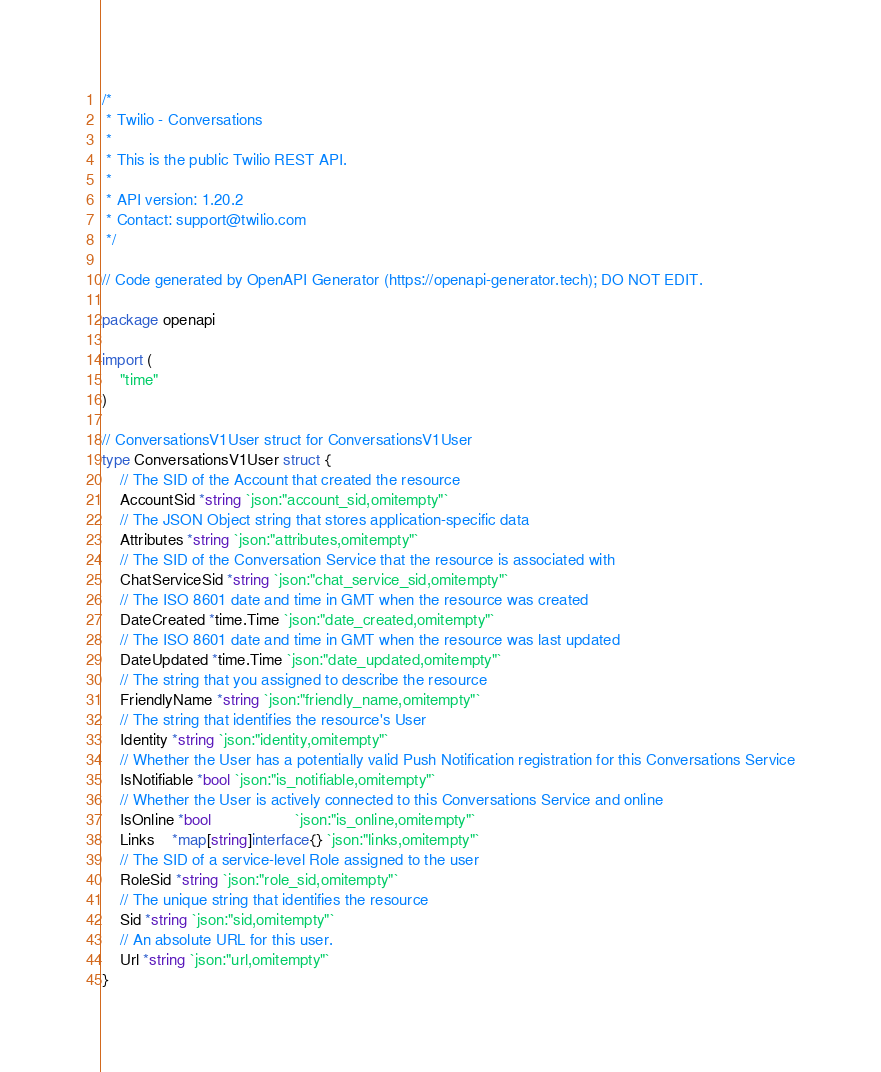<code> <loc_0><loc_0><loc_500><loc_500><_Go_>/*
 * Twilio - Conversations
 *
 * This is the public Twilio REST API.
 *
 * API version: 1.20.2
 * Contact: support@twilio.com
 */

// Code generated by OpenAPI Generator (https://openapi-generator.tech); DO NOT EDIT.

package openapi

import (
	"time"
)

// ConversationsV1User struct for ConversationsV1User
type ConversationsV1User struct {
	// The SID of the Account that created the resource
	AccountSid *string `json:"account_sid,omitempty"`
	// The JSON Object string that stores application-specific data
	Attributes *string `json:"attributes,omitempty"`
	// The SID of the Conversation Service that the resource is associated with
	ChatServiceSid *string `json:"chat_service_sid,omitempty"`
	// The ISO 8601 date and time in GMT when the resource was created
	DateCreated *time.Time `json:"date_created,omitempty"`
	// The ISO 8601 date and time in GMT when the resource was last updated
	DateUpdated *time.Time `json:"date_updated,omitempty"`
	// The string that you assigned to describe the resource
	FriendlyName *string `json:"friendly_name,omitempty"`
	// The string that identifies the resource's User
	Identity *string `json:"identity,omitempty"`
	// Whether the User has a potentially valid Push Notification registration for this Conversations Service
	IsNotifiable *bool `json:"is_notifiable,omitempty"`
	// Whether the User is actively connected to this Conversations Service and online
	IsOnline *bool                   `json:"is_online,omitempty"`
	Links    *map[string]interface{} `json:"links,omitempty"`
	// The SID of a service-level Role assigned to the user
	RoleSid *string `json:"role_sid,omitempty"`
	// The unique string that identifies the resource
	Sid *string `json:"sid,omitempty"`
	// An absolute URL for this user.
	Url *string `json:"url,omitempty"`
}
</code> 